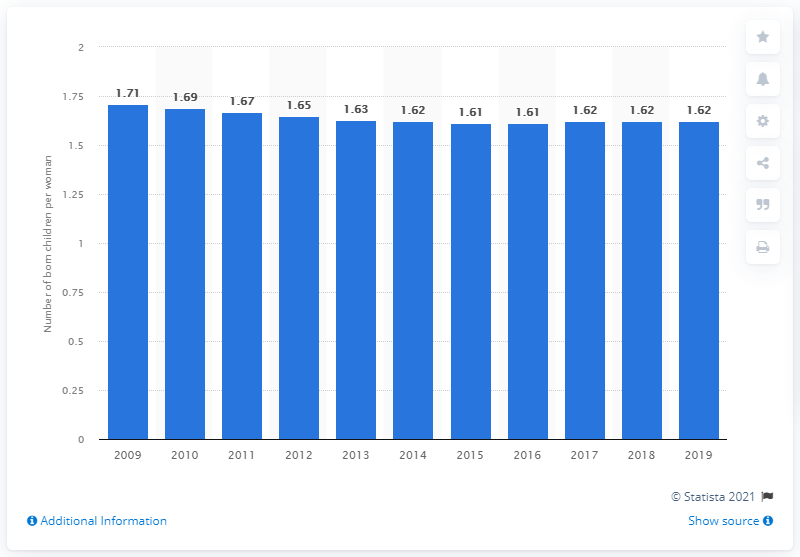Outline some significant characteristics in this image. In 2019, the fertility rate in Barbados was 1.62. 